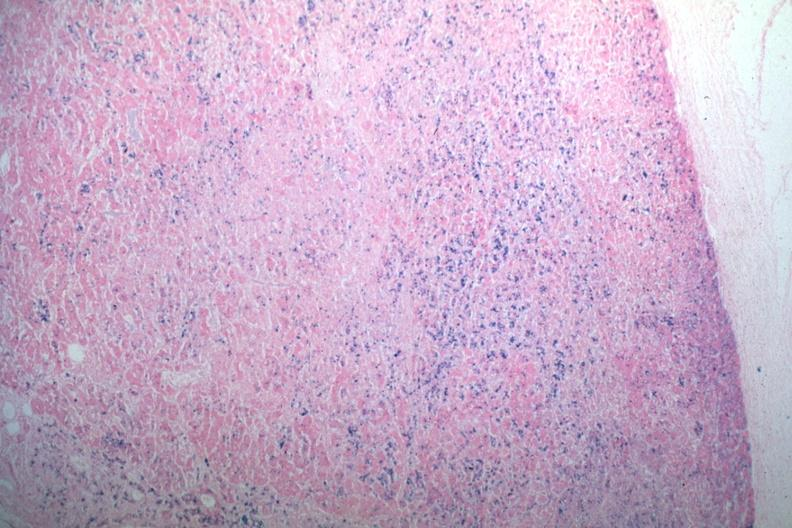what is present?
Answer the question using a single word or phrase. Hemochromatosis 